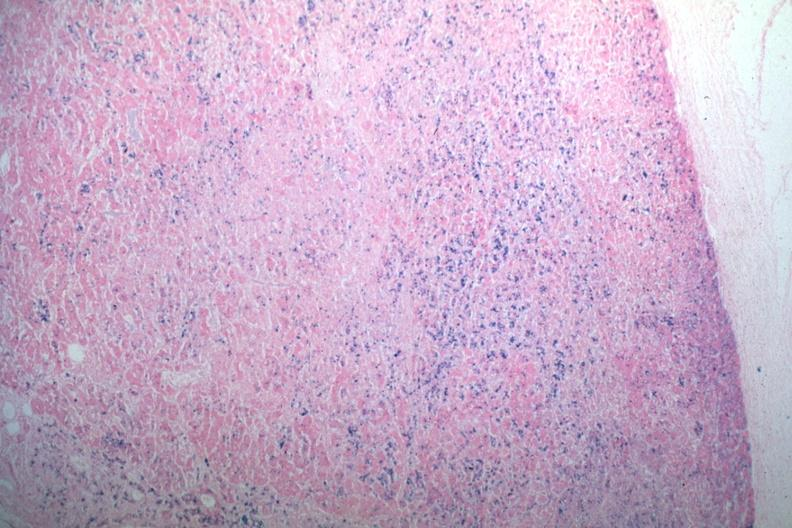what is present?
Answer the question using a single word or phrase. Hemochromatosis 